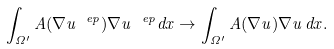<formula> <loc_0><loc_0><loc_500><loc_500>\int _ { \Omega ^ { \prime } } A ( \nabla u ^ { \ e p } ) \nabla u ^ { \ e p } d x \rightarrow \int _ { \Omega ^ { \prime } } A ( \nabla u ) \nabla u \, d x .</formula> 